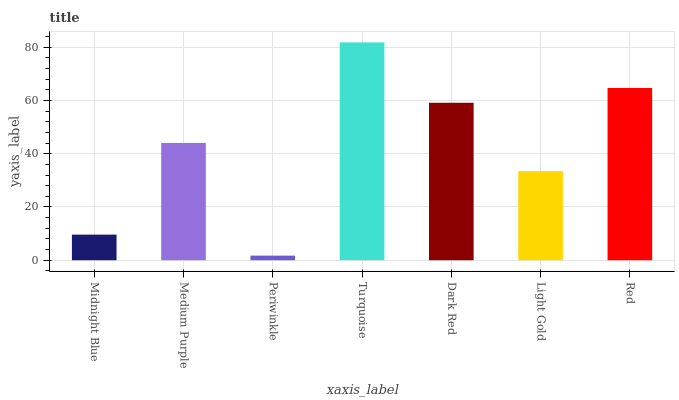Is Periwinkle the minimum?
Answer yes or no. Yes. Is Turquoise the maximum?
Answer yes or no. Yes. Is Medium Purple the minimum?
Answer yes or no. No. Is Medium Purple the maximum?
Answer yes or no. No. Is Medium Purple greater than Midnight Blue?
Answer yes or no. Yes. Is Midnight Blue less than Medium Purple?
Answer yes or no. Yes. Is Midnight Blue greater than Medium Purple?
Answer yes or no. No. Is Medium Purple less than Midnight Blue?
Answer yes or no. No. Is Medium Purple the high median?
Answer yes or no. Yes. Is Medium Purple the low median?
Answer yes or no. Yes. Is Light Gold the high median?
Answer yes or no. No. Is Periwinkle the low median?
Answer yes or no. No. 